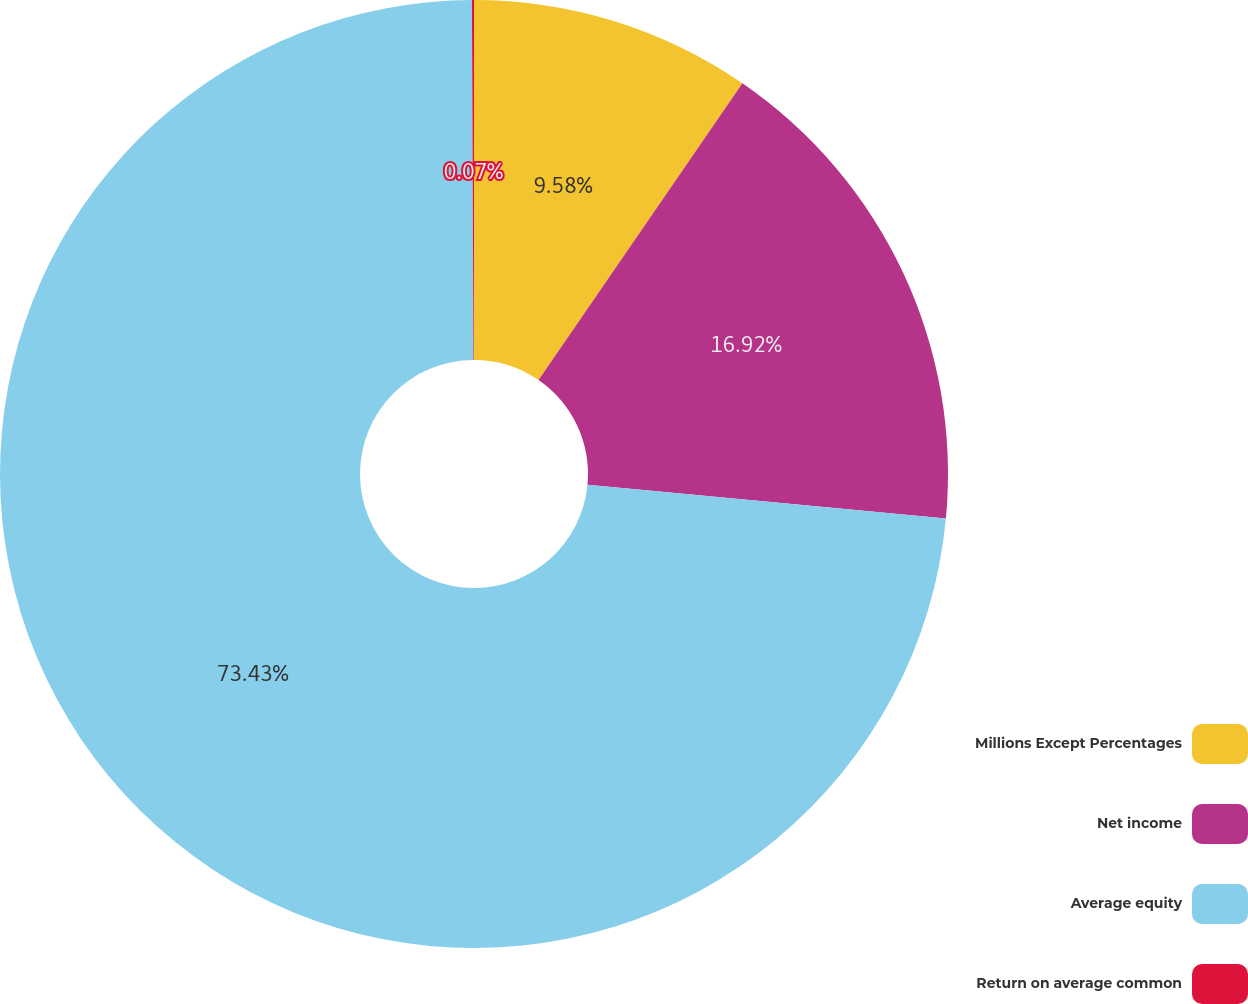Convert chart. <chart><loc_0><loc_0><loc_500><loc_500><pie_chart><fcel>Millions Except Percentages<fcel>Net income<fcel>Average equity<fcel>Return on average common<nl><fcel>9.58%<fcel>16.92%<fcel>73.43%<fcel>0.07%<nl></chart> 